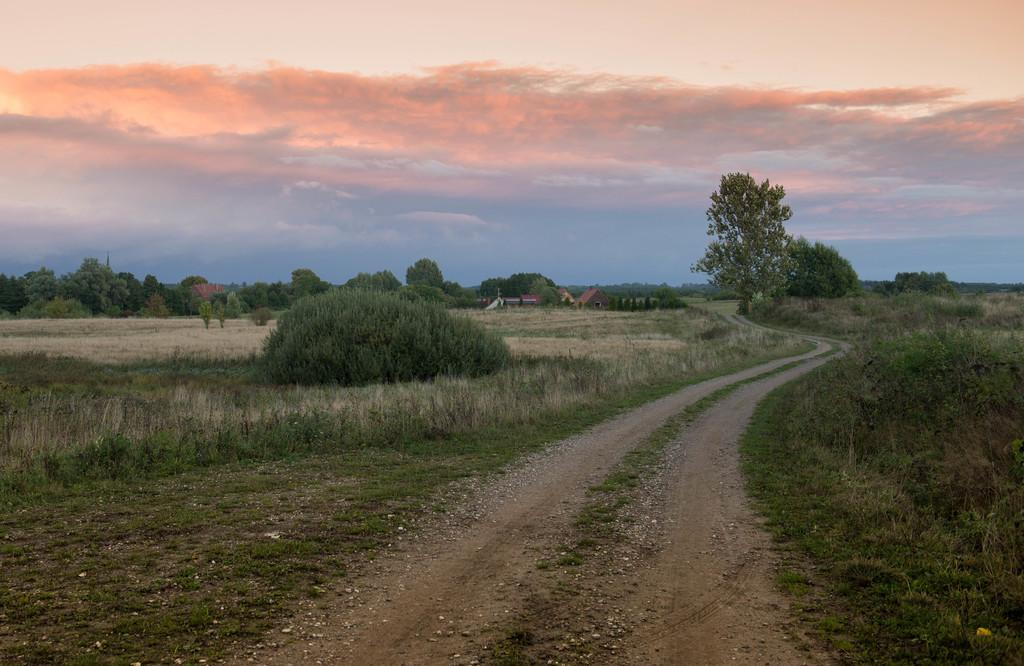What is the main feature of the image? There is a pathway in the image. What is the ground surface like on either side of the pathway? On either side of the pathway, there is a grass surface. What can be found on the grass surface? Plants are present on the grass surface. What can be seen in the background of the image? There are trees, houses, and the sky visible in the background of the image. What is the condition of the sky in the image? Clouds are present in the sky. Where is the nest of the vessel located in the image? There is no vessel or nest present in the image. What type of yarn is being used to create the plants in the image? The plants in the image are not made of yarn; they are real plants growing on the grass surface. 